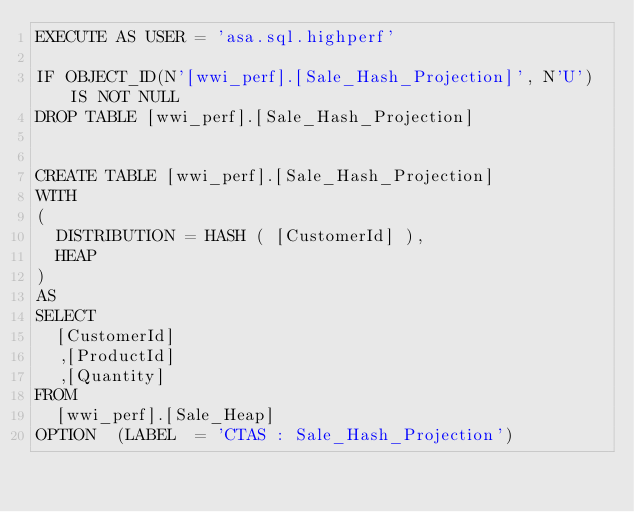<code> <loc_0><loc_0><loc_500><loc_500><_SQL_>EXECUTE AS USER = 'asa.sql.highperf'

IF OBJECT_ID(N'[wwi_perf].[Sale_Hash_Projection]', N'U') IS NOT NULL   
DROP TABLE [wwi_perf].[Sale_Hash_Projection]


CREATE TABLE [wwi_perf].[Sale_Hash_Projection]
WITH
(
	DISTRIBUTION = HASH ( [CustomerId] ),
	HEAP
)
AS
SELECT
	[CustomerId]
	,[ProductId]
	,[Quantity]
FROM
	[wwi_perf].[Sale_Heap]
OPTION  (LABEL  = 'CTAS : Sale_Hash_Projection')</code> 